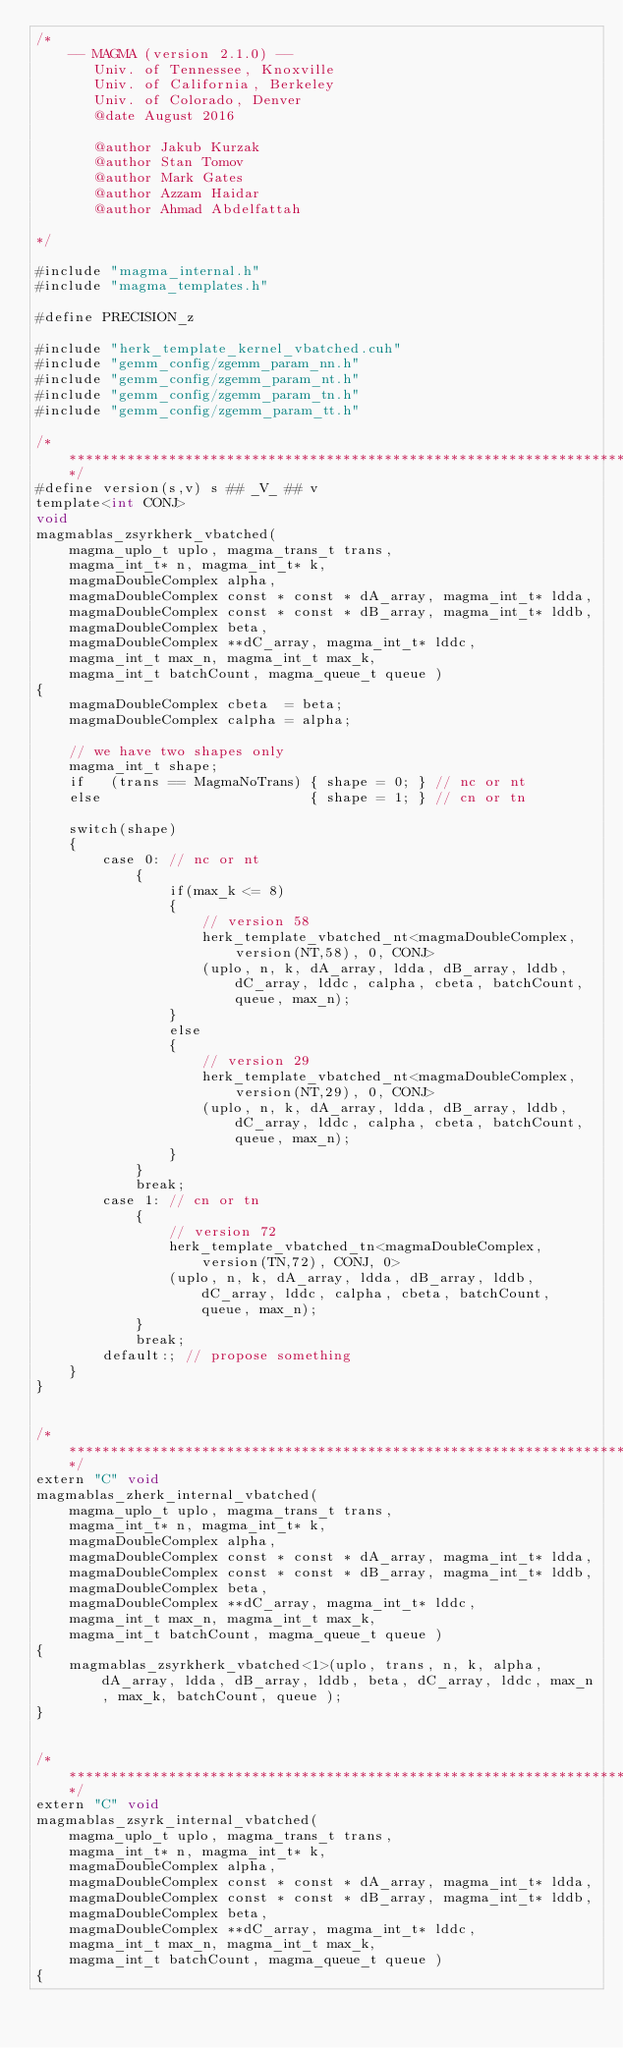Convert code to text. <code><loc_0><loc_0><loc_500><loc_500><_Cuda_>/*
    -- MAGMA (version 2.1.0) --
       Univ. of Tennessee, Knoxville
       Univ. of California, Berkeley
       Univ. of Colorado, Denver
       @date August 2016

       @author Jakub Kurzak
       @author Stan Tomov
       @author Mark Gates
       @author Azzam Haidar
       @author Ahmad Abdelfattah
       
*/

#include "magma_internal.h"
#include "magma_templates.h"

#define PRECISION_z

#include "herk_template_kernel_vbatched.cuh"
#include "gemm_config/zgemm_param_nn.h"
#include "gemm_config/zgemm_param_nt.h"
#include "gemm_config/zgemm_param_tn.h"
#include "gemm_config/zgemm_param_tt.h"

/******************************************************************************/
#define version(s,v) s ## _V_ ## v
template<int CONJ>
void
magmablas_zsyrkherk_vbatched(
    magma_uplo_t uplo, magma_trans_t trans, 
    magma_int_t* n, magma_int_t* k,
    magmaDoubleComplex alpha,
    magmaDoubleComplex const * const * dA_array, magma_int_t* ldda,
    magmaDoubleComplex const * const * dB_array, magma_int_t* lddb,
    magmaDoubleComplex beta,
    magmaDoubleComplex **dC_array, magma_int_t* lddc, 
    magma_int_t max_n, magma_int_t max_k, 
    magma_int_t batchCount, magma_queue_t queue )
{
    magmaDoubleComplex cbeta  = beta;
    magmaDoubleComplex calpha = alpha;

    // we have two shapes only
    magma_int_t shape;
    if   (trans == MagmaNoTrans) { shape = 0; } // nc or nt
    else                         { shape = 1; } // cn or tn
        
    switch(shape)
    {
        case 0: // nc or nt
            {
                if(max_k <= 8)
                {
                    // version 58
                    herk_template_vbatched_nt<magmaDoubleComplex, version(NT,58), 0, CONJ>
                    (uplo, n, k, dA_array, ldda, dB_array, lddb, dC_array, lddc, calpha, cbeta, batchCount, queue, max_n);
                }
                else
                {
                    // version 29
                    herk_template_vbatched_nt<magmaDoubleComplex, version(NT,29), 0, CONJ>
                    (uplo, n, k, dA_array, ldda, dB_array, lddb, dC_array, lddc, calpha, cbeta, batchCount, queue, max_n);
                }
            }
            break;
        case 1: // cn or tn
            {
                // version 72
                herk_template_vbatched_tn<magmaDoubleComplex, version(TN,72), CONJ, 0>
                (uplo, n, k, dA_array, ldda, dB_array, lddb, dC_array, lddc, calpha, cbeta, batchCount, queue, max_n);
            }
            break;
        default:; // propose something
    }
}


/******************************************************************************/
extern "C" void
magmablas_zherk_internal_vbatched(
    magma_uplo_t uplo, magma_trans_t trans, 
    magma_int_t* n, magma_int_t* k,
    magmaDoubleComplex alpha,
    magmaDoubleComplex const * const * dA_array, magma_int_t* ldda,
    magmaDoubleComplex const * const * dB_array, magma_int_t* lddb,
    magmaDoubleComplex beta,
    magmaDoubleComplex **dC_array, magma_int_t* lddc, 
    magma_int_t max_n, magma_int_t max_k, 
    magma_int_t batchCount, magma_queue_t queue )
{
    magmablas_zsyrkherk_vbatched<1>(uplo, trans, n, k, alpha, dA_array, ldda, dB_array, lddb, beta, dC_array, lddc, max_n, max_k, batchCount, queue );
}


/******************************************************************************/
extern "C" void
magmablas_zsyrk_internal_vbatched(
    magma_uplo_t uplo, magma_trans_t trans, 
    magma_int_t* n, magma_int_t* k,
    magmaDoubleComplex alpha,
    magmaDoubleComplex const * const * dA_array, magma_int_t* ldda,
    magmaDoubleComplex const * const * dB_array, magma_int_t* lddb,
    magmaDoubleComplex beta,
    magmaDoubleComplex **dC_array, magma_int_t* lddc, 
    magma_int_t max_n, magma_int_t max_k, 
    magma_int_t batchCount, magma_queue_t queue )
{</code> 